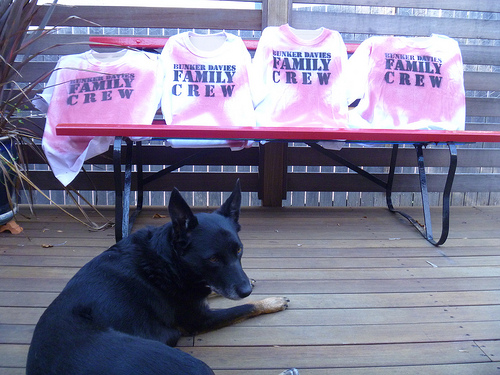<image>
Is there a dog on the porch? Yes. Looking at the image, I can see the dog is positioned on top of the porch, with the porch providing support. Where is the shirt in relation to the dog? Is it on the dog? No. The shirt is not positioned on the dog. They may be near each other, but the shirt is not supported by or resting on top of the dog. 